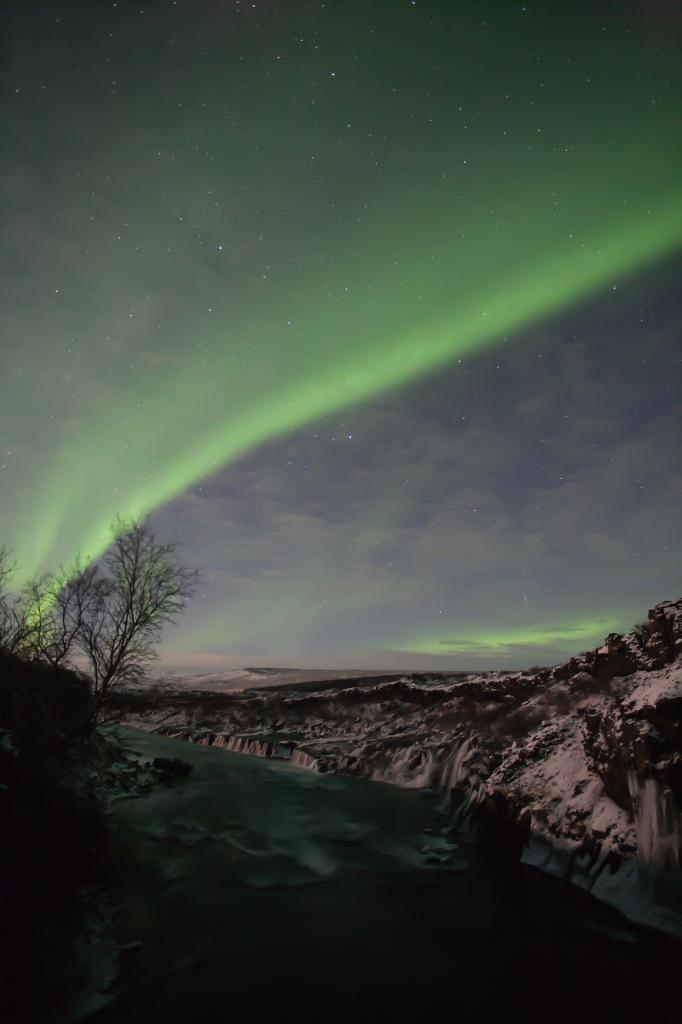What type of natural landscape can be seen on the left side of the image? There are trees on a hill near a river on the left side of the image. What is the river's condition in the image? The river has water in the image. What is the terrain like on the right side of the image? There is a snow hill on the right side of the image. What can be seen in the sky in the background of the image? There are clouds and stars visible in the sky in the background. Can you see any snails crawling on the snow hill in the image? There are no snails visible in the image, as it focuses on the natural landscape and does not include any animals or insects. 